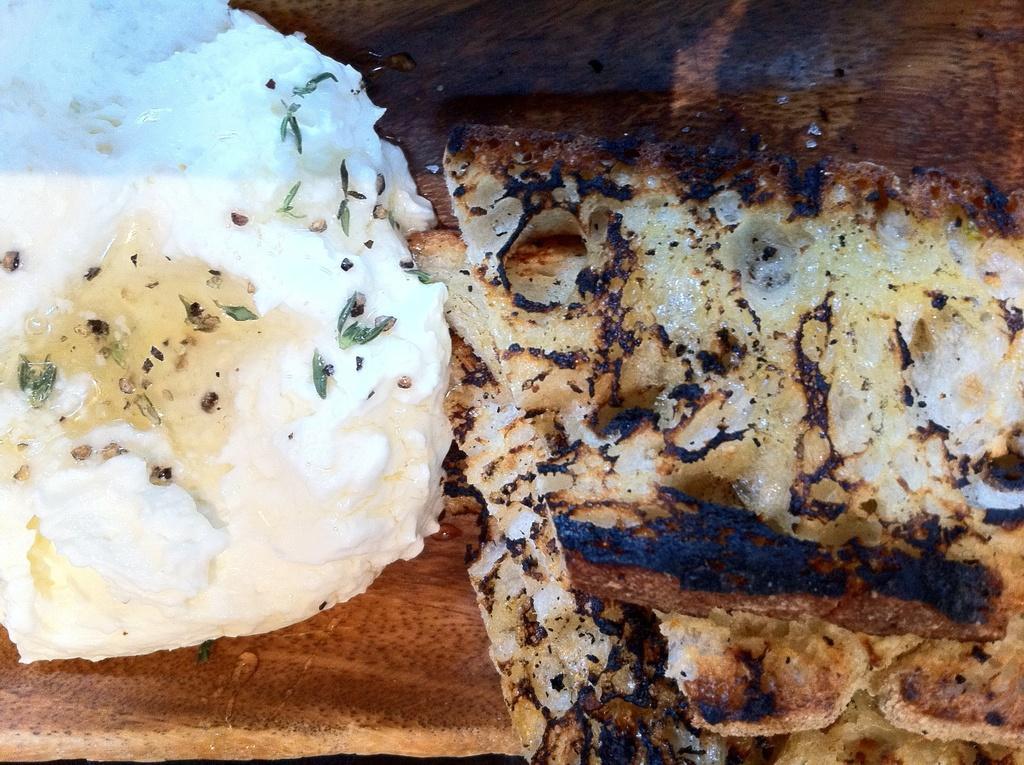In one or two sentences, can you explain what this image depicts? In this picture we can see food items placed on a wooden platform. 